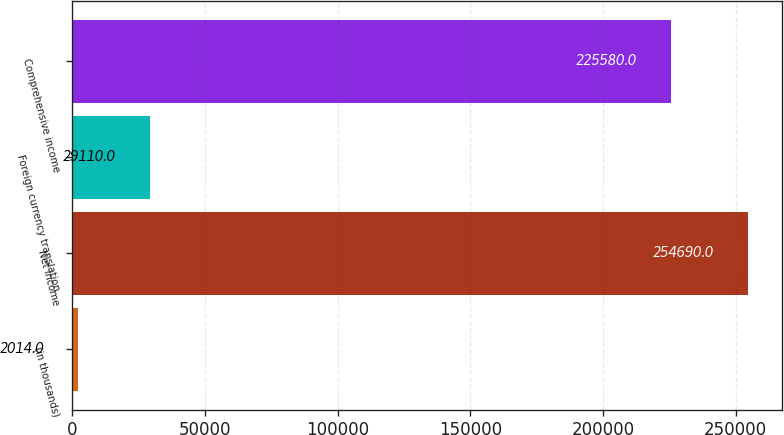Convert chart. <chart><loc_0><loc_0><loc_500><loc_500><bar_chart><fcel>(in thousands)<fcel>Net income<fcel>Foreign currency translation<fcel>Comprehensive income<nl><fcel>2014<fcel>254690<fcel>29110<fcel>225580<nl></chart> 